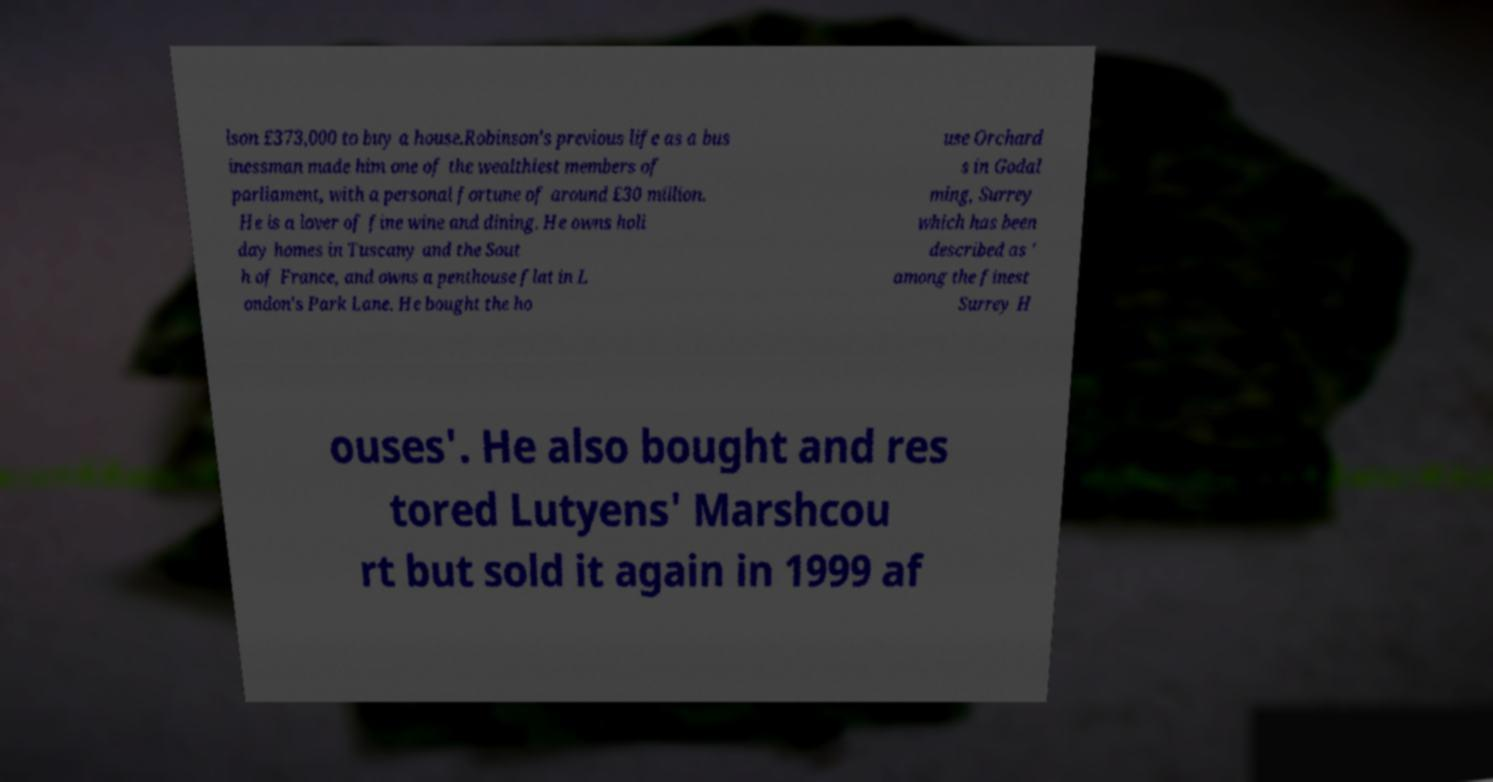Please read and relay the text visible in this image. What does it say? lson £373,000 to buy a house.Robinson's previous life as a bus inessman made him one of the wealthiest members of parliament, with a personal fortune of around £30 million. He is a lover of fine wine and dining. He owns holi day homes in Tuscany and the Sout h of France, and owns a penthouse flat in L ondon's Park Lane. He bought the ho use Orchard s in Godal ming, Surrey which has been described as ' among the finest Surrey H ouses'. He also bought and res tored Lutyens' Marshcou rt but sold it again in 1999 af 